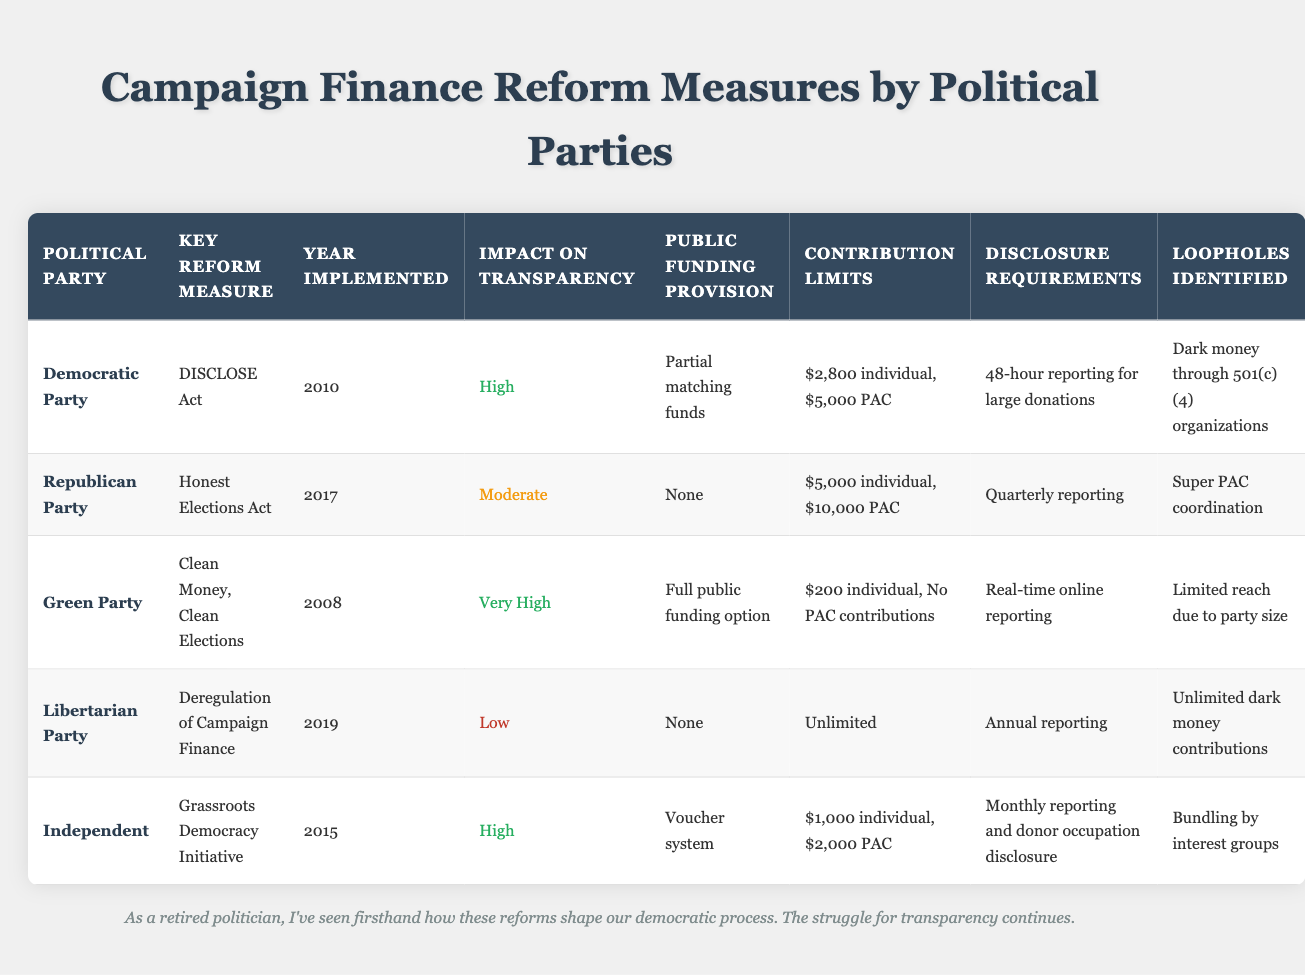What key reform measure did the Libertarian Party implement? The table shows that the Libertarian Party implemented the "Deregulation of Campaign Finance" as their key reform measure.
Answer: Deregulation of Campaign Finance Which political party has the highest impact on transparency? From the table, the Green Party's measure, "Clean Money, Clean Elections," is marked as having "Very High" impact on transparency, which is the highest listed.
Answer: Green Party What are the contribution limits for individuals according to the Republican Party's reform? The table indicates that the Republican Party's "Honest Elections Act" has contribution limits of "$5,000 individual."
Answer: $5,000 individual Did the Democratic Party provide full public funding for their campaign financing reform? According to the table, the Democratic Party's "DISCLOSE Act" offers "Partial matching funds," which means they do not provide full public funding.
Answer: No What is the difference in individual contribution limits between the Green Party and the Libertarian Party? The Green Party has a limit of "$200 individual," while the Libertarian Party has "Unlimited" contributions. The difference is calculated as Unlimited - 200, which signifies that the Libertarian Party does not restrict.
Answer: Unlimited - $200 = Unlimited Which reform measures require monthly or more frequent disclosure reports? The Independent's "Grassroots Democracy Initiative" requires "Monthly reporting," while the Democratic Party requires "48-hour reporting." Thus, the only frequent requirement is from the Independent Party.
Answer: Independent Party How many political parties provide any form of public funding according to the table? From the table, three parties provide some form of public funding: the Democratic Party offers "Partial matching funds," the Green Party has a "Full public funding option," and the Independent has a "Voucher system." Hence, this totals to three parties.
Answer: Three parties What loopholes have been identified in the Green Party's reform? The table notes that the Green Party's reform has been identified with a loophole: "Limited reach due to party size."
Answer: Limited reach due to party size Which political parties have implemented reforms after 2015? The Republican Party implemented the "Honest Elections Act" in 2017 and the Libertarian Party enacted "Deregulation of Campaign Finance" in 2019. So, there are two parties with reforms after 2015.
Answer: Two parties 